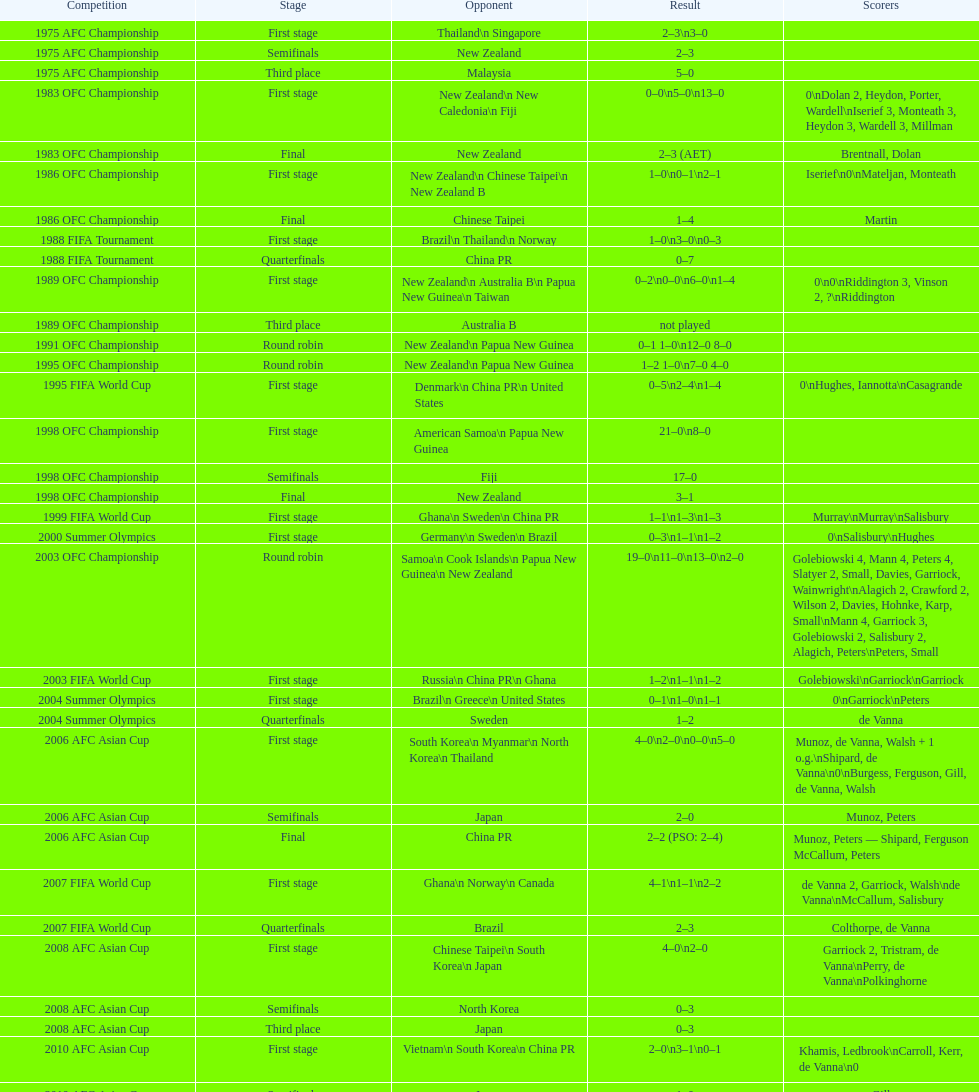Write the full table. {'header': ['Competition', 'Stage', 'Opponent', 'Result', 'Scorers'], 'rows': [['1975 AFC Championship', 'First stage', 'Thailand\\n\xa0Singapore', '2–3\\n3–0', ''], ['1975 AFC Championship', 'Semifinals', 'New Zealand', '2–3', ''], ['1975 AFC Championship', 'Third place', 'Malaysia', '5–0', ''], ['1983 OFC Championship', 'First stage', 'New Zealand\\n\xa0New Caledonia\\n\xa0Fiji', '0–0\\n5–0\\n13–0', '0\\nDolan 2, Heydon, Porter, Wardell\\nIserief 3, Monteath 3, Heydon 3, Wardell 3, Millman'], ['1983 OFC Championship', 'Final', 'New Zealand', '2–3 (AET)', 'Brentnall, Dolan'], ['1986 OFC Championship', 'First stage', 'New Zealand\\n\xa0Chinese Taipei\\n New Zealand B', '1–0\\n0–1\\n2–1', 'Iserief\\n0\\nMateljan, Monteath'], ['1986 OFC Championship', 'Final', 'Chinese Taipei', '1–4', 'Martin'], ['1988 FIFA Tournament', 'First stage', 'Brazil\\n\xa0Thailand\\n\xa0Norway', '1–0\\n3–0\\n0–3', ''], ['1988 FIFA Tournament', 'Quarterfinals', 'China PR', '0–7', ''], ['1989 OFC Championship', 'First stage', 'New Zealand\\n Australia B\\n\xa0Papua New Guinea\\n\xa0Taiwan', '0–2\\n0–0\\n6–0\\n1–4', '0\\n0\\nRiddington 3, Vinson 2,\xa0?\\nRiddington'], ['1989 OFC Championship', 'Third place', 'Australia B', 'not played', ''], ['1991 OFC Championship', 'Round robin', 'New Zealand\\n\xa0Papua New Guinea', '0–1 1–0\\n12–0 8–0', ''], ['1995 OFC Championship', 'Round robin', 'New Zealand\\n\xa0Papua New Guinea', '1–2 1–0\\n7–0 4–0', ''], ['1995 FIFA World Cup', 'First stage', 'Denmark\\n\xa0China PR\\n\xa0United States', '0–5\\n2–4\\n1–4', '0\\nHughes, Iannotta\\nCasagrande'], ['1998 OFC Championship', 'First stage', 'American Samoa\\n\xa0Papua New Guinea', '21–0\\n8–0', ''], ['1998 OFC Championship', 'Semifinals', 'Fiji', '17–0', ''], ['1998 OFC Championship', 'Final', 'New Zealand', '3–1', ''], ['1999 FIFA World Cup', 'First stage', 'Ghana\\n\xa0Sweden\\n\xa0China PR', '1–1\\n1–3\\n1–3', 'Murray\\nMurray\\nSalisbury'], ['2000 Summer Olympics', 'First stage', 'Germany\\n\xa0Sweden\\n\xa0Brazil', '0–3\\n1–1\\n1–2', '0\\nSalisbury\\nHughes'], ['2003 OFC Championship', 'Round robin', 'Samoa\\n\xa0Cook Islands\\n\xa0Papua New Guinea\\n\xa0New Zealand', '19–0\\n11–0\\n13–0\\n2–0', 'Golebiowski 4, Mann 4, Peters 4, Slatyer 2, Small, Davies, Garriock, Wainwright\\nAlagich 2, Crawford 2, Wilson 2, Davies, Hohnke, Karp, Small\\nMann 4, Garriock 3, Golebiowski 2, Salisbury 2, Alagich, Peters\\nPeters, Small'], ['2003 FIFA World Cup', 'First stage', 'Russia\\n\xa0China PR\\n\xa0Ghana', '1–2\\n1–1\\n1–2', 'Golebiowski\\nGarriock\\nGarriock'], ['2004 Summer Olympics', 'First stage', 'Brazil\\n\xa0Greece\\n\xa0United States', '0–1\\n1–0\\n1–1', '0\\nGarriock\\nPeters'], ['2004 Summer Olympics', 'Quarterfinals', 'Sweden', '1–2', 'de Vanna'], ['2006 AFC Asian Cup', 'First stage', 'South Korea\\n\xa0Myanmar\\n\xa0North Korea\\n\xa0Thailand', '4–0\\n2–0\\n0–0\\n5–0', 'Munoz, de Vanna, Walsh + 1 o.g.\\nShipard, de Vanna\\n0\\nBurgess, Ferguson, Gill, de Vanna, Walsh'], ['2006 AFC Asian Cup', 'Semifinals', 'Japan', '2–0', 'Munoz, Peters'], ['2006 AFC Asian Cup', 'Final', 'China PR', '2–2 (PSO: 2–4)', 'Munoz, Peters — Shipard, Ferguson McCallum, Peters'], ['2007 FIFA World Cup', 'First stage', 'Ghana\\n\xa0Norway\\n\xa0Canada', '4–1\\n1–1\\n2–2', 'de Vanna 2, Garriock, Walsh\\nde Vanna\\nMcCallum, Salisbury'], ['2007 FIFA World Cup', 'Quarterfinals', 'Brazil', '2–3', 'Colthorpe, de Vanna'], ['2008 AFC Asian Cup', 'First stage', 'Chinese Taipei\\n\xa0South Korea\\n\xa0Japan', '4–0\\n2–0', 'Garriock 2, Tristram, de Vanna\\nPerry, de Vanna\\nPolkinghorne'], ['2008 AFC Asian Cup', 'Semifinals', 'North Korea', '0–3', ''], ['2008 AFC Asian Cup', 'Third place', 'Japan', '0–3', ''], ['2010 AFC Asian Cup', 'First stage', 'Vietnam\\n\xa0South Korea\\n\xa0China PR', '2–0\\n3–1\\n0–1', 'Khamis, Ledbrook\\nCarroll, Kerr, de Vanna\\n0'], ['2010 AFC Asian Cup', 'Semifinals', 'Japan', '1–0', 'Gill'], ['2010 AFC Asian Cup', 'Final', 'North Korea', '1–1 (PSO: 5–4)', 'Kerr — PSO: Shipard, Ledbrook, Gill, Garriock, Simon'], ['2011 FIFA World Cup', 'First stage', 'Brazil\\n\xa0Equatorial Guinea\\n\xa0Norway', '0–1\\n3–2\\n2–1', '0\\nvan Egmond, Khamis, de Vanna\\nSimon 2'], ['2011 FIFA World Cup', 'Quarterfinals', 'Sweden', '1–3', 'Perry'], ['2012 Summer Olympics\\nAFC qualification', 'Final round', 'North Korea\\n\xa0Thailand\\n\xa0Japan\\n\xa0China PR\\n\xa0South Korea', '0–1\\n5–1\\n0–1\\n1–0\\n2–1', '0\\nHeyman 2, Butt, van Egmond, Simon\\n0\\nvan Egmond\\nButt, de Vanna'], ['2014 AFC Asian Cup', 'First stage', 'Japan\\n\xa0Jordan\\n\xa0Vietnam', 'TBD\\nTBD\\nTBD', '']]} During the 1983 ofc championship contest, how many players registered goals? 9. 